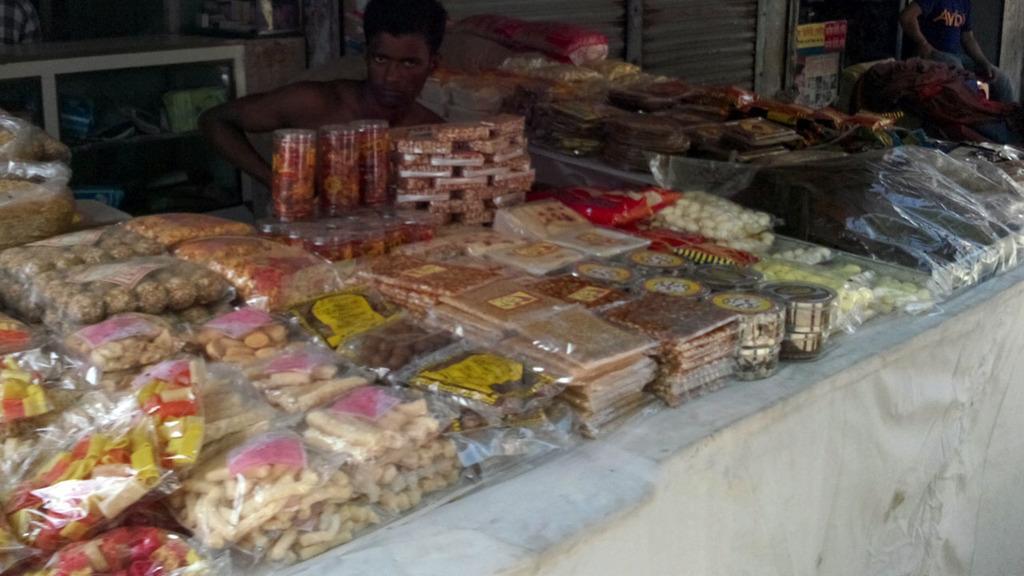In one or two sentences, can you explain what this image depicts? In this image I can see many food item packs and a person is sitting at the back. There is a shutter and another person is present at the right back. 